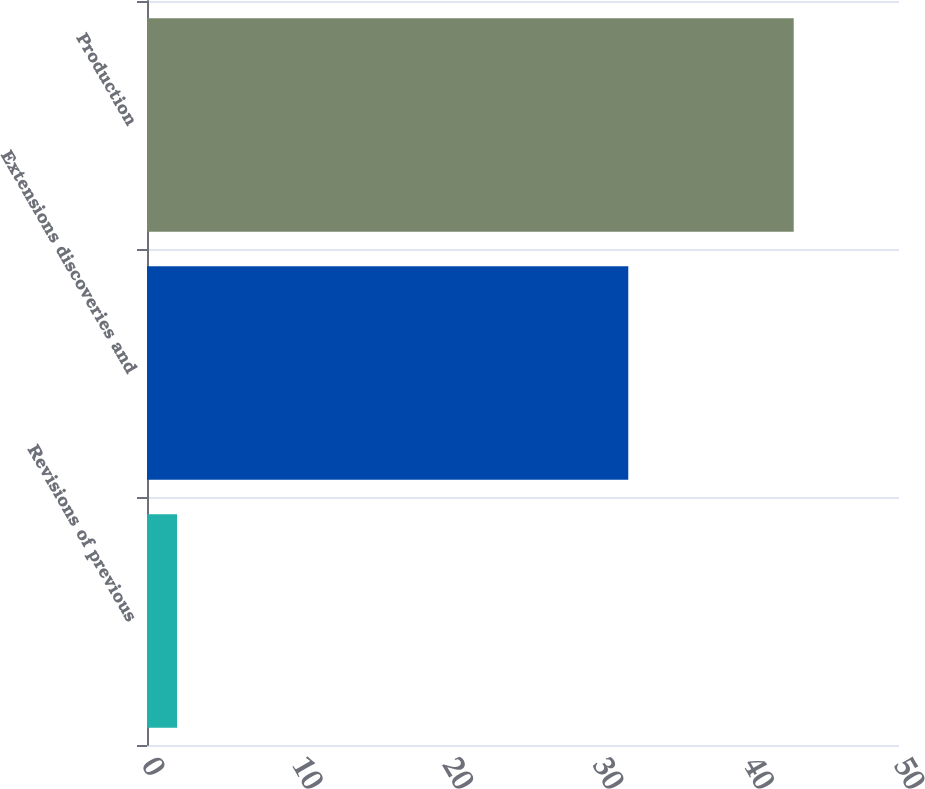Convert chart to OTSL. <chart><loc_0><loc_0><loc_500><loc_500><bar_chart><fcel>Revisions of previous<fcel>Extensions discoveries and<fcel>Production<nl><fcel>2<fcel>32<fcel>43<nl></chart> 